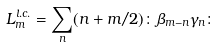Convert formula to latex. <formula><loc_0><loc_0><loc_500><loc_500>L _ { m } ^ { l . c . } = \sum _ { n } ( n + m / 2 ) \colon \beta _ { m - n } \gamma _ { n } \colon</formula> 